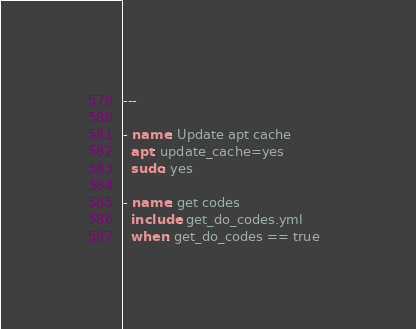Convert code to text. <code><loc_0><loc_0><loc_500><loc_500><_YAML_>---

- name: Update apt cache
  apt: update_cache=yes
  sudo: yes

- name: get codes  
  include: get_do_codes.yml
  when: get_do_codes == true  
</code> 